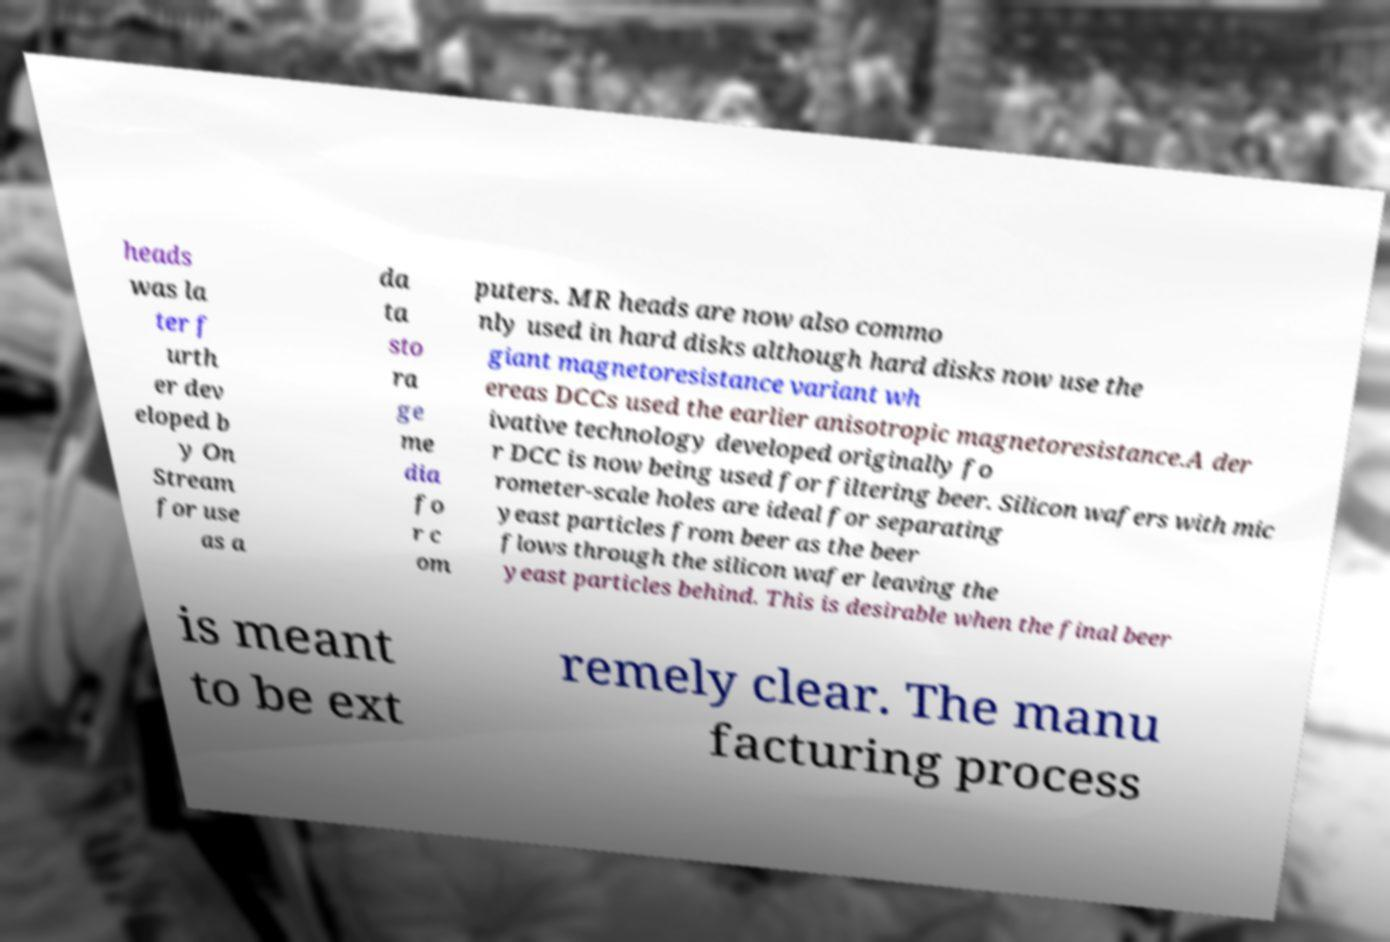Please identify and transcribe the text found in this image. heads was la ter f urth er dev eloped b y On Stream for use as a da ta sto ra ge me dia fo r c om puters. MR heads are now also commo nly used in hard disks although hard disks now use the giant magnetoresistance variant wh ereas DCCs used the earlier anisotropic magnetoresistance.A der ivative technology developed originally fo r DCC is now being used for filtering beer. Silicon wafers with mic rometer-scale holes are ideal for separating yeast particles from beer as the beer flows through the silicon wafer leaving the yeast particles behind. This is desirable when the final beer is meant to be ext remely clear. The manu facturing process 